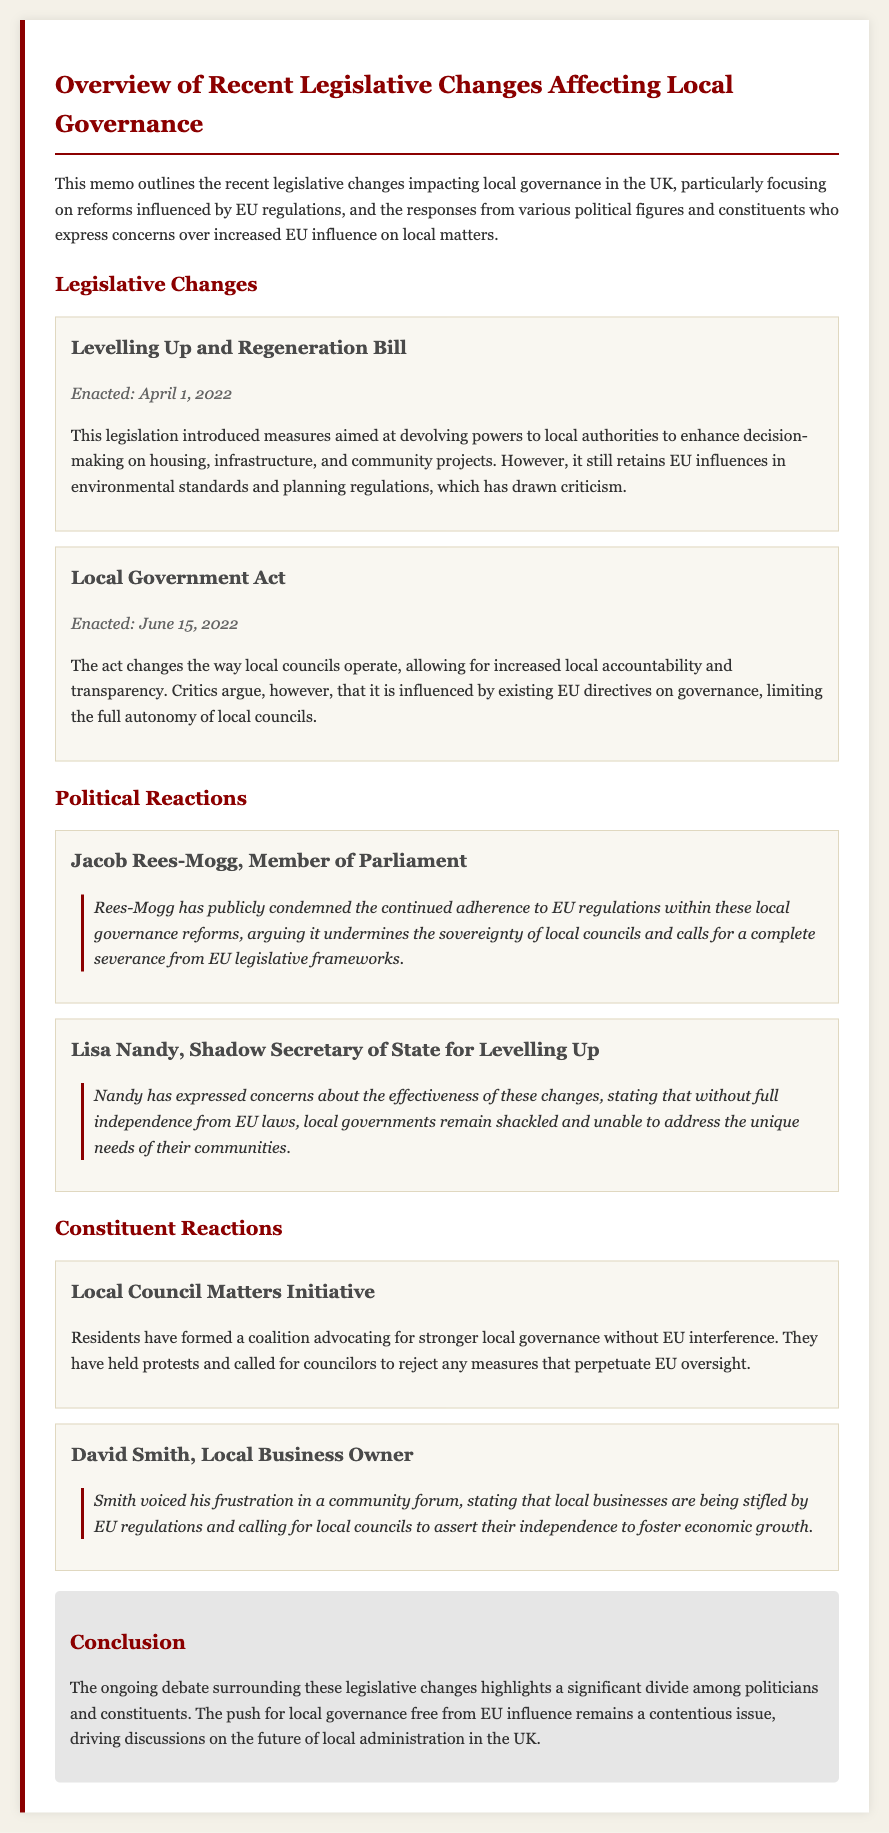What is the title of the memo? The title of the memo is found in the header section of the document.
Answer: Overview of Recent Legislative Changes Affecting Local Governance When was the Levelling Up and Regeneration Bill enacted? The enactment date is noted within the legislative changes section.
Answer: April 1, 2022 Who condemned EU regulations in local governance reforms? The name of the politician who condemned EU regulations is mentioned in the political reactions section.
Answer: Jacob Rees-Mogg What are the constituents advocating for? The request of the constituents is highlighted in their reactions within the document.
Answer: Stronger local governance without EU interference What did David Smith express at the community forum? David Smith's sentiments regarding local business regulations can be found in the constituent reactions.
Answer: Frustration about EU regulations stifling local businesses What is the concern raised by Lisa Nandy? Lisa Nandy's concern regarding the new legislative changes is included in her reaction.
Answer: Without full independence from EU laws, local governments remain shackled Which act changed the way local councils operate? The act that introduced changes to local council operations is identified in the legislative changes section.
Answer: Local Government Act What was the date of enactment for the Local Government Act? The date for this act is specified in the legislative changes section of the memo.
Answer: June 15, 2022 What major issue does the memo conclude with? The conclusion summarizes the primary debate noted in the document.
Answer: The significant divide among politicians and constituents regarding EU influence 